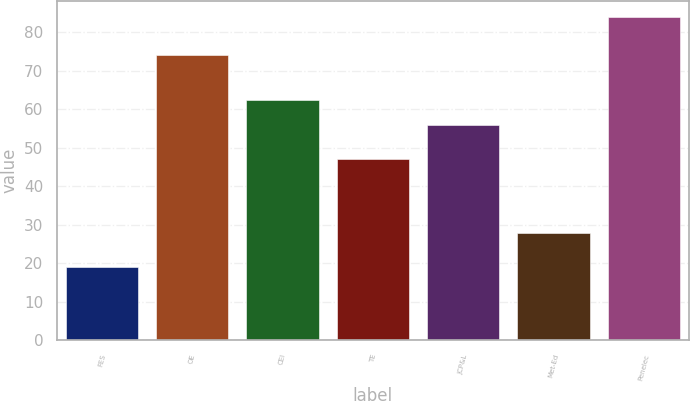<chart> <loc_0><loc_0><loc_500><loc_500><bar_chart><fcel>FES<fcel>OE<fcel>CEI<fcel>TE<fcel>JCP&L<fcel>Met-Ed<fcel>Penelec<nl><fcel>19<fcel>74<fcel>62.5<fcel>47<fcel>56<fcel>28<fcel>84<nl></chart> 